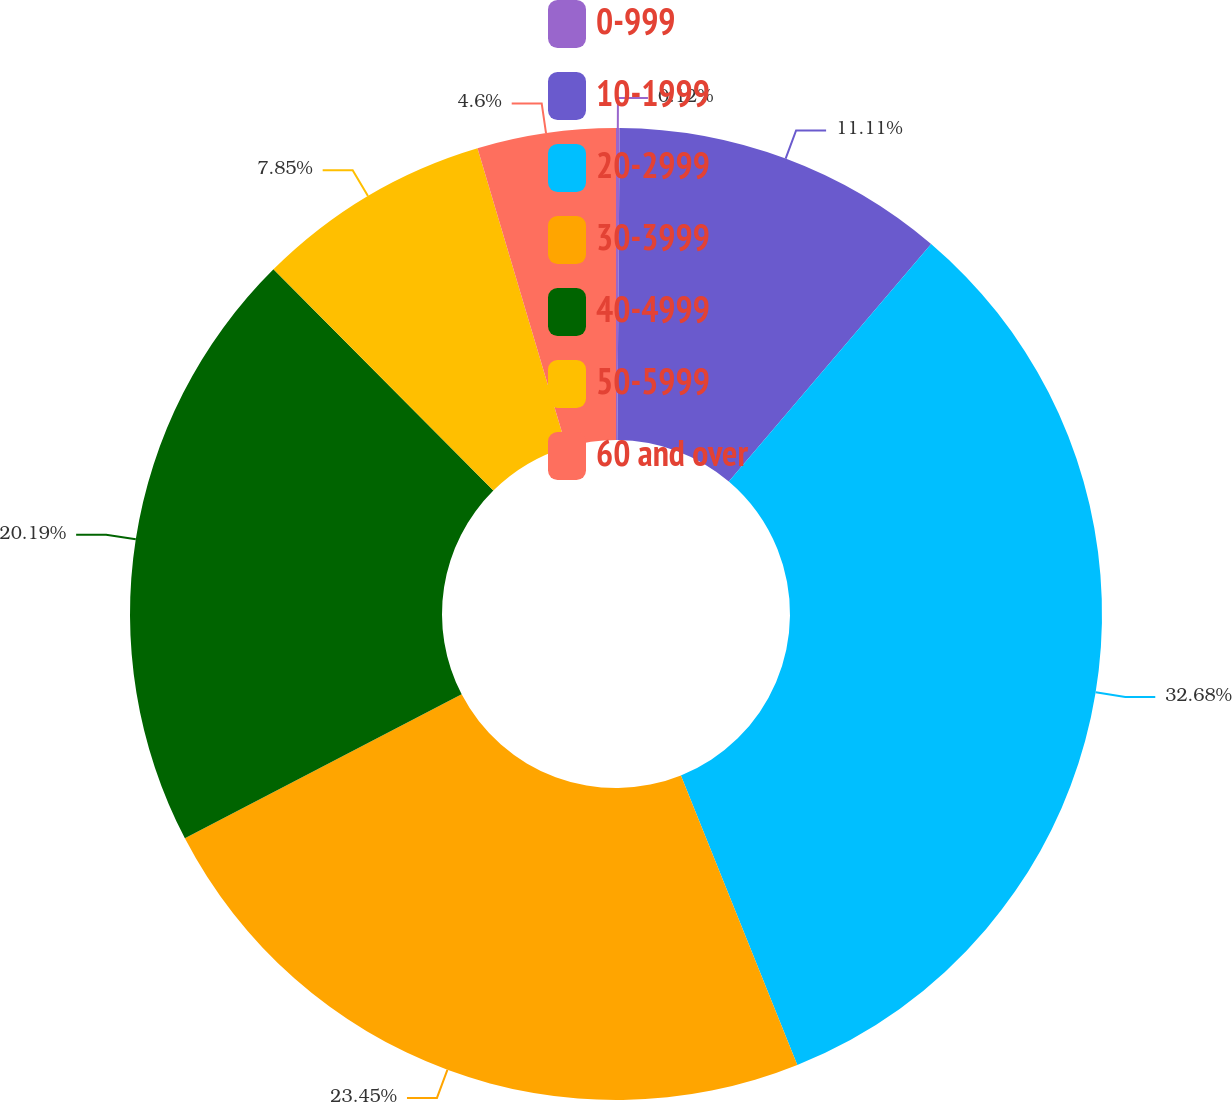Convert chart to OTSL. <chart><loc_0><loc_0><loc_500><loc_500><pie_chart><fcel>0-999<fcel>10-1999<fcel>20-2999<fcel>30-3999<fcel>40-4999<fcel>50-5999<fcel>60 and over<nl><fcel>0.12%<fcel>11.11%<fcel>32.69%<fcel>23.45%<fcel>20.19%<fcel>7.85%<fcel>4.6%<nl></chart> 